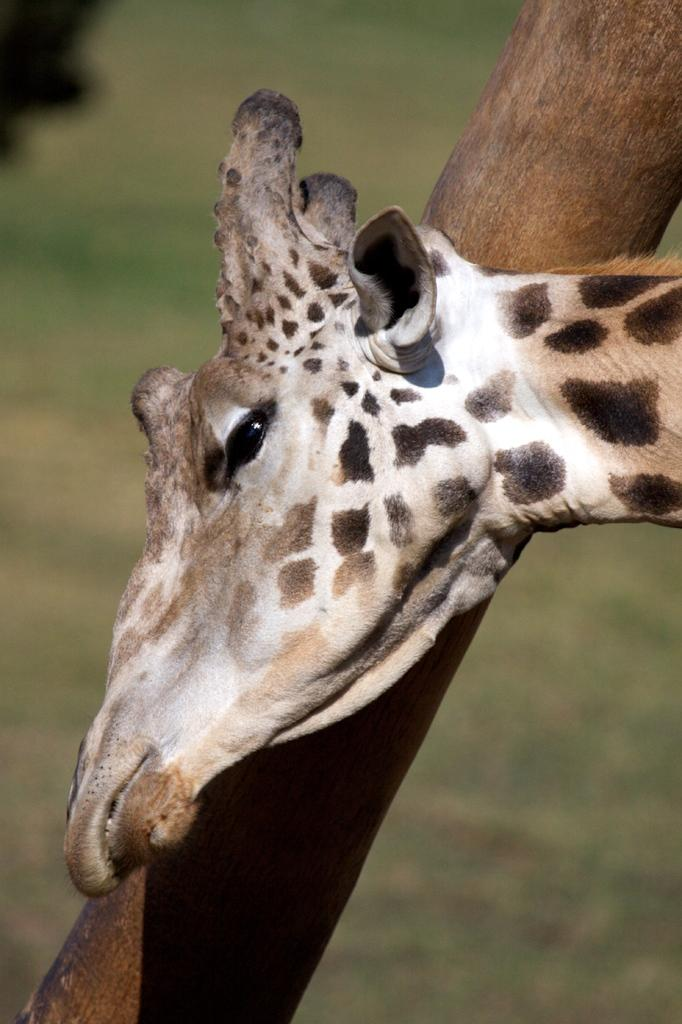What animal's head is visible in the image? The image contains the head of a giraffe. What object can be seen in the image besides the giraffe's head? There is a wooden pole in the image. Can you describe the background of the image? The background of the image is blurry. Where is the faucet located in the image? There is no faucet present in the image. What type of drink is the robin holding in the image? There is no robin or drink present in the image. 